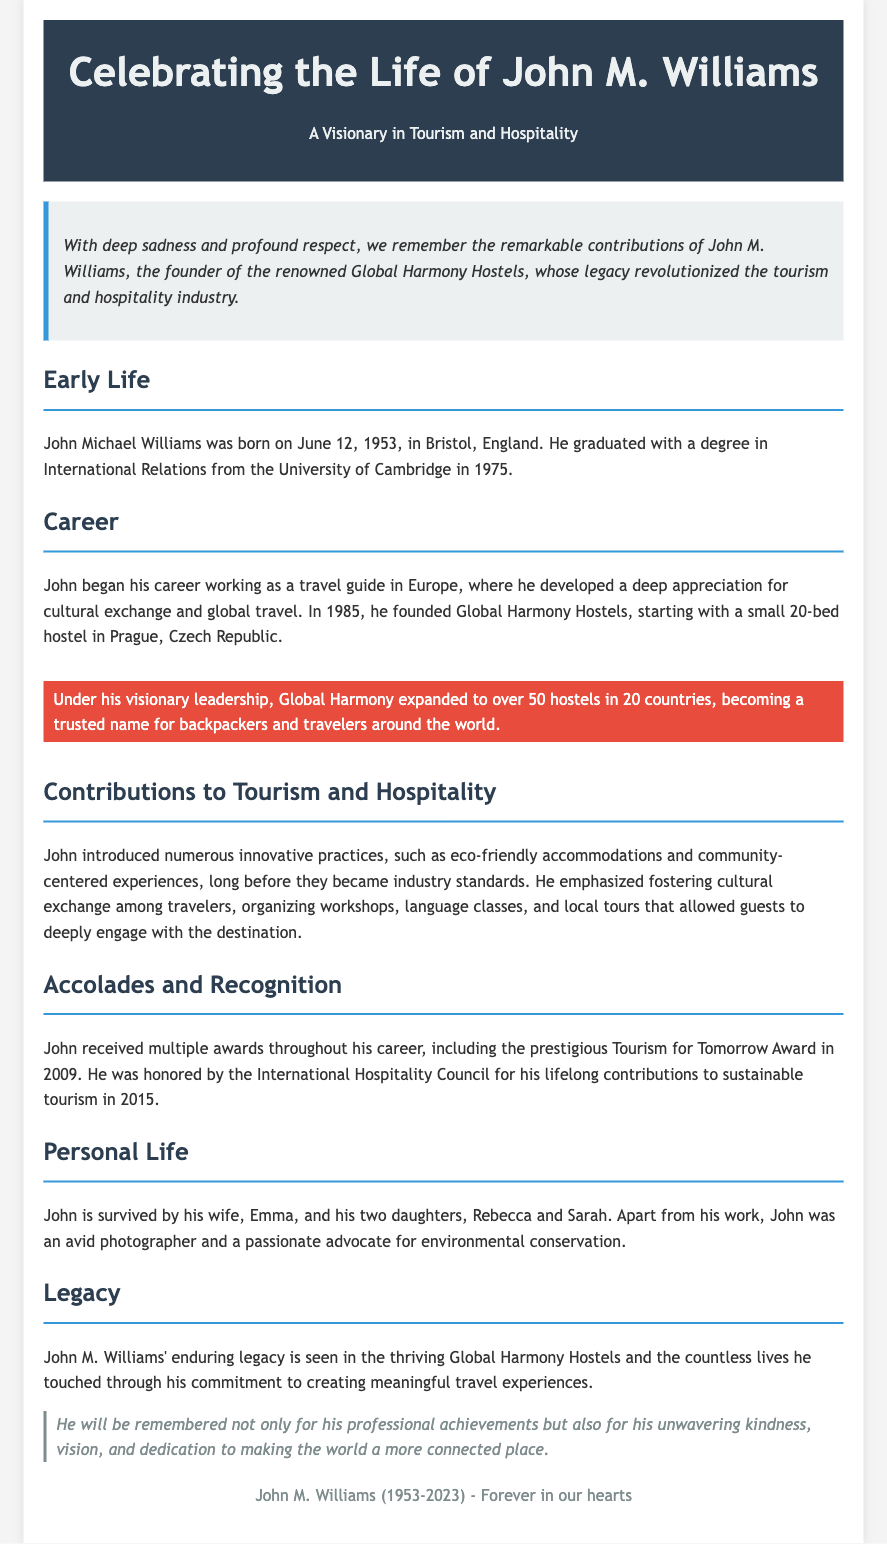what was John M. Williams' birth date? The birth date is stated clearly in the Early Life section of the document.
Answer: June 12, 1953 what degree did John M. Williams graduate with? The document mentions his educational background, specifying the degree he obtained from Cambridge.
Answer: International Relations how many hostels did Global Harmony Hostels expand to under John's leadership? The Career section highlights the number of hostels established during his leadership.
Answer: over 50 what prestigious award did John receive in 2009? The Accolades and Recognition section lists the awards he received, including the one in 2009.
Answer: Tourism for Tomorrow Award who is John M. Williams survived by? The Personal Life section provides information on his family members who survived him.
Answer: Emma, Rebecca, and Sarah what innovative practices did John introduce in the hospitality industry? The Contributions to Tourism and Hospitality section outlines significant practices he introduced.
Answer: eco-friendly accommodations and community-centered experiences which city did John M. Williams start his first hostel? The Career section specifies the location of the first hostel he founded.
Answer: Prague what is John M. Williams' legacy in tourism? The Legacy section summarizes the impact he had on the tourism industry through his work.
Answer: meaningful travel experiences 